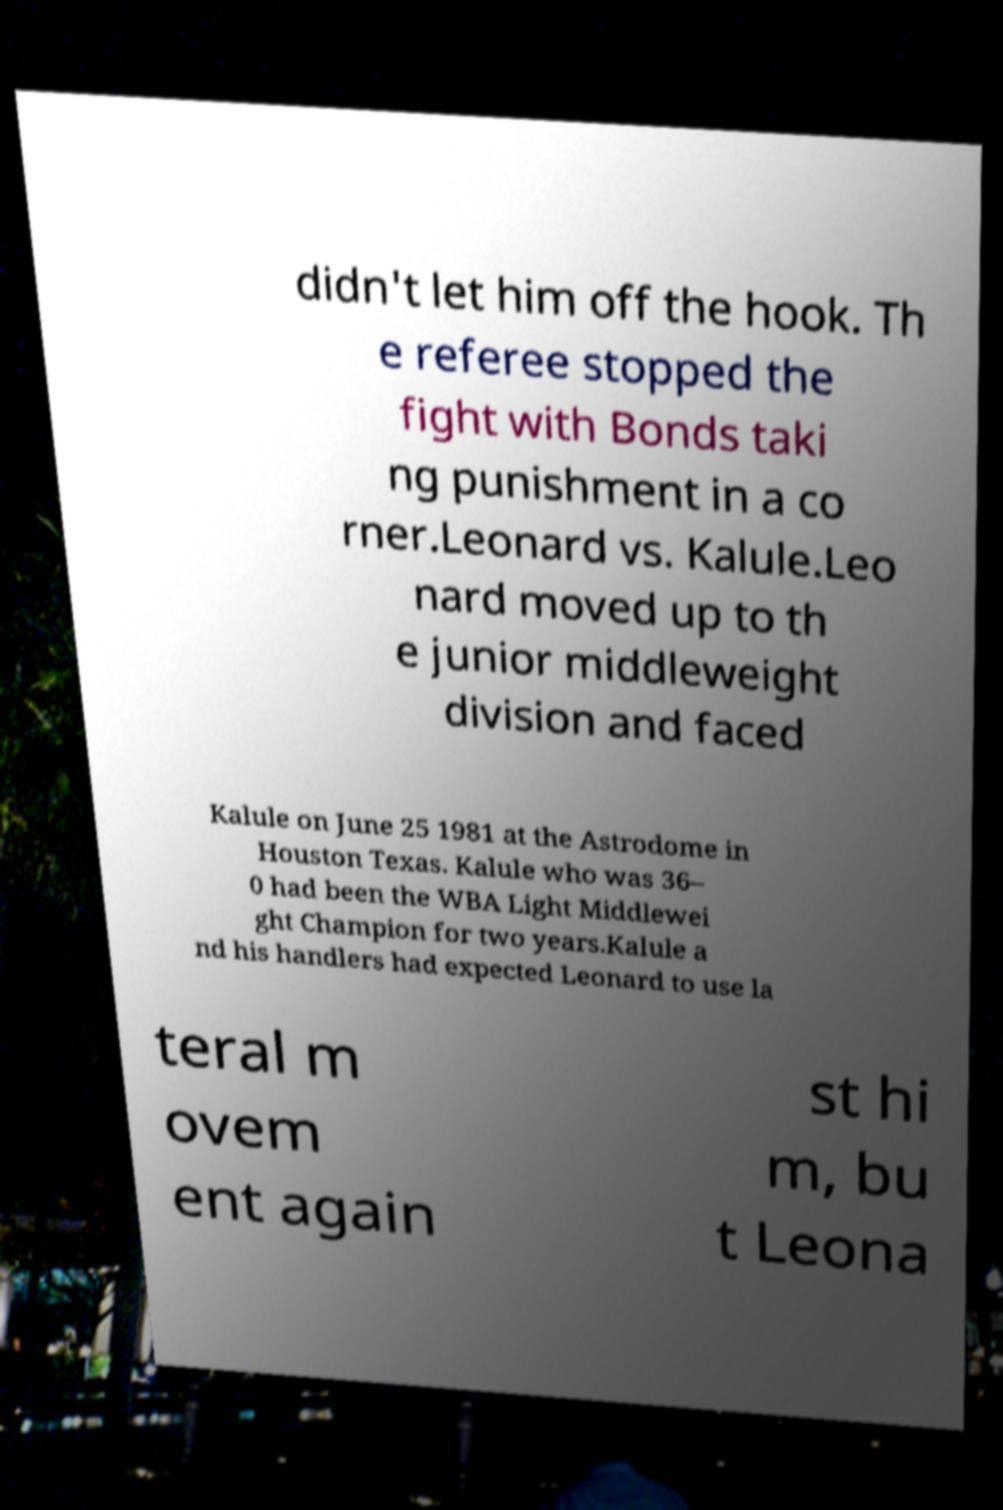Please identify and transcribe the text found in this image. didn't let him off the hook. Th e referee stopped the fight with Bonds taki ng punishment in a co rner.Leonard vs. Kalule.Leo nard moved up to th e junior middleweight division and faced Kalule on June 25 1981 at the Astrodome in Houston Texas. Kalule who was 36– 0 had been the WBA Light Middlewei ght Champion for two years.Kalule a nd his handlers had expected Leonard to use la teral m ovem ent again st hi m, bu t Leona 